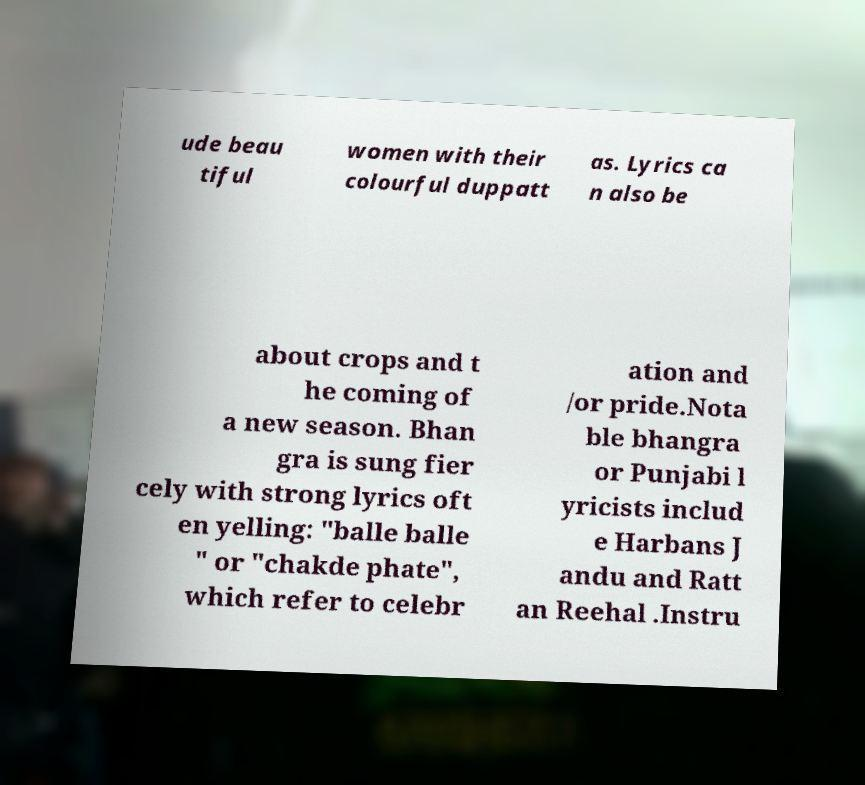What messages or text are displayed in this image? I need them in a readable, typed format. ude beau tiful women with their colourful duppatt as. Lyrics ca n also be about crops and t he coming of a new season. Bhan gra is sung fier cely with strong lyrics oft en yelling: "balle balle " or "chakde phate", which refer to celebr ation and /or pride.Nota ble bhangra or Punjabi l yricists includ e Harbans J andu and Ratt an Reehal .Instru 